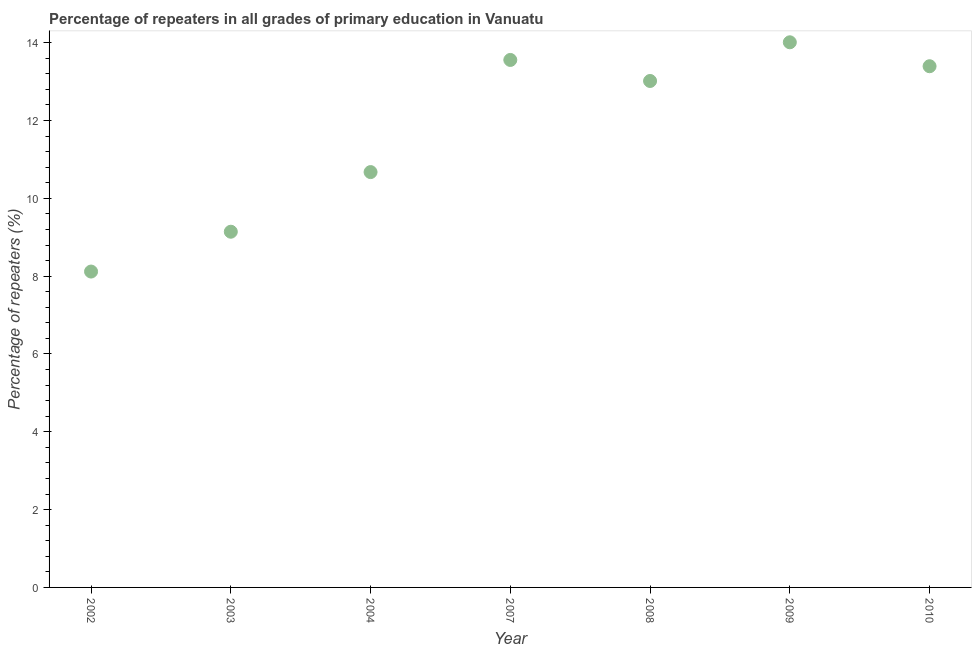What is the percentage of repeaters in primary education in 2010?
Offer a terse response. 13.4. Across all years, what is the maximum percentage of repeaters in primary education?
Your answer should be very brief. 14.01. Across all years, what is the minimum percentage of repeaters in primary education?
Offer a terse response. 8.12. In which year was the percentage of repeaters in primary education maximum?
Your response must be concise. 2009. What is the sum of the percentage of repeaters in primary education?
Provide a short and direct response. 81.92. What is the difference between the percentage of repeaters in primary education in 2003 and 2008?
Give a very brief answer. -3.87. What is the average percentage of repeaters in primary education per year?
Make the answer very short. 11.7. What is the median percentage of repeaters in primary education?
Make the answer very short. 13.02. In how many years, is the percentage of repeaters in primary education greater than 10 %?
Provide a succinct answer. 5. Do a majority of the years between 2003 and 2004 (inclusive) have percentage of repeaters in primary education greater than 2.4 %?
Your answer should be compact. Yes. What is the ratio of the percentage of repeaters in primary education in 2007 to that in 2010?
Your response must be concise. 1.01. Is the difference between the percentage of repeaters in primary education in 2003 and 2004 greater than the difference between any two years?
Your answer should be compact. No. What is the difference between the highest and the second highest percentage of repeaters in primary education?
Keep it short and to the point. 0.45. Is the sum of the percentage of repeaters in primary education in 2004 and 2007 greater than the maximum percentage of repeaters in primary education across all years?
Offer a very short reply. Yes. What is the difference between the highest and the lowest percentage of repeaters in primary education?
Provide a short and direct response. 5.89. What is the difference between two consecutive major ticks on the Y-axis?
Your answer should be compact. 2. Are the values on the major ticks of Y-axis written in scientific E-notation?
Your answer should be compact. No. Does the graph contain any zero values?
Ensure brevity in your answer.  No. Does the graph contain grids?
Your answer should be compact. No. What is the title of the graph?
Provide a short and direct response. Percentage of repeaters in all grades of primary education in Vanuatu. What is the label or title of the Y-axis?
Ensure brevity in your answer.  Percentage of repeaters (%). What is the Percentage of repeaters (%) in 2002?
Offer a terse response. 8.12. What is the Percentage of repeaters (%) in 2003?
Give a very brief answer. 9.14. What is the Percentage of repeaters (%) in 2004?
Ensure brevity in your answer.  10.68. What is the Percentage of repeaters (%) in 2007?
Make the answer very short. 13.56. What is the Percentage of repeaters (%) in 2008?
Your answer should be compact. 13.02. What is the Percentage of repeaters (%) in 2009?
Your answer should be very brief. 14.01. What is the Percentage of repeaters (%) in 2010?
Make the answer very short. 13.4. What is the difference between the Percentage of repeaters (%) in 2002 and 2003?
Keep it short and to the point. -1.02. What is the difference between the Percentage of repeaters (%) in 2002 and 2004?
Your answer should be compact. -2.56. What is the difference between the Percentage of repeaters (%) in 2002 and 2007?
Offer a terse response. -5.44. What is the difference between the Percentage of repeaters (%) in 2002 and 2008?
Provide a succinct answer. -4.9. What is the difference between the Percentage of repeaters (%) in 2002 and 2009?
Provide a succinct answer. -5.89. What is the difference between the Percentage of repeaters (%) in 2002 and 2010?
Provide a succinct answer. -5.28. What is the difference between the Percentage of repeaters (%) in 2003 and 2004?
Give a very brief answer. -1.53. What is the difference between the Percentage of repeaters (%) in 2003 and 2007?
Make the answer very short. -4.42. What is the difference between the Percentage of repeaters (%) in 2003 and 2008?
Your answer should be compact. -3.87. What is the difference between the Percentage of repeaters (%) in 2003 and 2009?
Ensure brevity in your answer.  -4.87. What is the difference between the Percentage of repeaters (%) in 2003 and 2010?
Your answer should be compact. -4.25. What is the difference between the Percentage of repeaters (%) in 2004 and 2007?
Your response must be concise. -2.88. What is the difference between the Percentage of repeaters (%) in 2004 and 2008?
Give a very brief answer. -2.34. What is the difference between the Percentage of repeaters (%) in 2004 and 2009?
Give a very brief answer. -3.34. What is the difference between the Percentage of repeaters (%) in 2004 and 2010?
Provide a succinct answer. -2.72. What is the difference between the Percentage of repeaters (%) in 2007 and 2008?
Offer a terse response. 0.54. What is the difference between the Percentage of repeaters (%) in 2007 and 2009?
Your response must be concise. -0.45. What is the difference between the Percentage of repeaters (%) in 2007 and 2010?
Your answer should be compact. 0.16. What is the difference between the Percentage of repeaters (%) in 2008 and 2009?
Offer a very short reply. -0.99. What is the difference between the Percentage of repeaters (%) in 2008 and 2010?
Your answer should be very brief. -0.38. What is the difference between the Percentage of repeaters (%) in 2009 and 2010?
Provide a short and direct response. 0.62. What is the ratio of the Percentage of repeaters (%) in 2002 to that in 2003?
Your answer should be compact. 0.89. What is the ratio of the Percentage of repeaters (%) in 2002 to that in 2004?
Make the answer very short. 0.76. What is the ratio of the Percentage of repeaters (%) in 2002 to that in 2007?
Give a very brief answer. 0.6. What is the ratio of the Percentage of repeaters (%) in 2002 to that in 2008?
Offer a very short reply. 0.62. What is the ratio of the Percentage of repeaters (%) in 2002 to that in 2009?
Your answer should be compact. 0.58. What is the ratio of the Percentage of repeaters (%) in 2002 to that in 2010?
Give a very brief answer. 0.61. What is the ratio of the Percentage of repeaters (%) in 2003 to that in 2004?
Make the answer very short. 0.86. What is the ratio of the Percentage of repeaters (%) in 2003 to that in 2007?
Your response must be concise. 0.67. What is the ratio of the Percentage of repeaters (%) in 2003 to that in 2008?
Provide a short and direct response. 0.7. What is the ratio of the Percentage of repeaters (%) in 2003 to that in 2009?
Your answer should be very brief. 0.65. What is the ratio of the Percentage of repeaters (%) in 2003 to that in 2010?
Offer a very short reply. 0.68. What is the ratio of the Percentage of repeaters (%) in 2004 to that in 2007?
Keep it short and to the point. 0.79. What is the ratio of the Percentage of repeaters (%) in 2004 to that in 2008?
Keep it short and to the point. 0.82. What is the ratio of the Percentage of repeaters (%) in 2004 to that in 2009?
Make the answer very short. 0.76. What is the ratio of the Percentage of repeaters (%) in 2004 to that in 2010?
Your response must be concise. 0.8. What is the ratio of the Percentage of repeaters (%) in 2007 to that in 2008?
Provide a succinct answer. 1.04. What is the ratio of the Percentage of repeaters (%) in 2007 to that in 2009?
Your response must be concise. 0.97. What is the ratio of the Percentage of repeaters (%) in 2007 to that in 2010?
Offer a very short reply. 1.01. What is the ratio of the Percentage of repeaters (%) in 2008 to that in 2009?
Your response must be concise. 0.93. What is the ratio of the Percentage of repeaters (%) in 2008 to that in 2010?
Offer a very short reply. 0.97. What is the ratio of the Percentage of repeaters (%) in 2009 to that in 2010?
Make the answer very short. 1.05. 